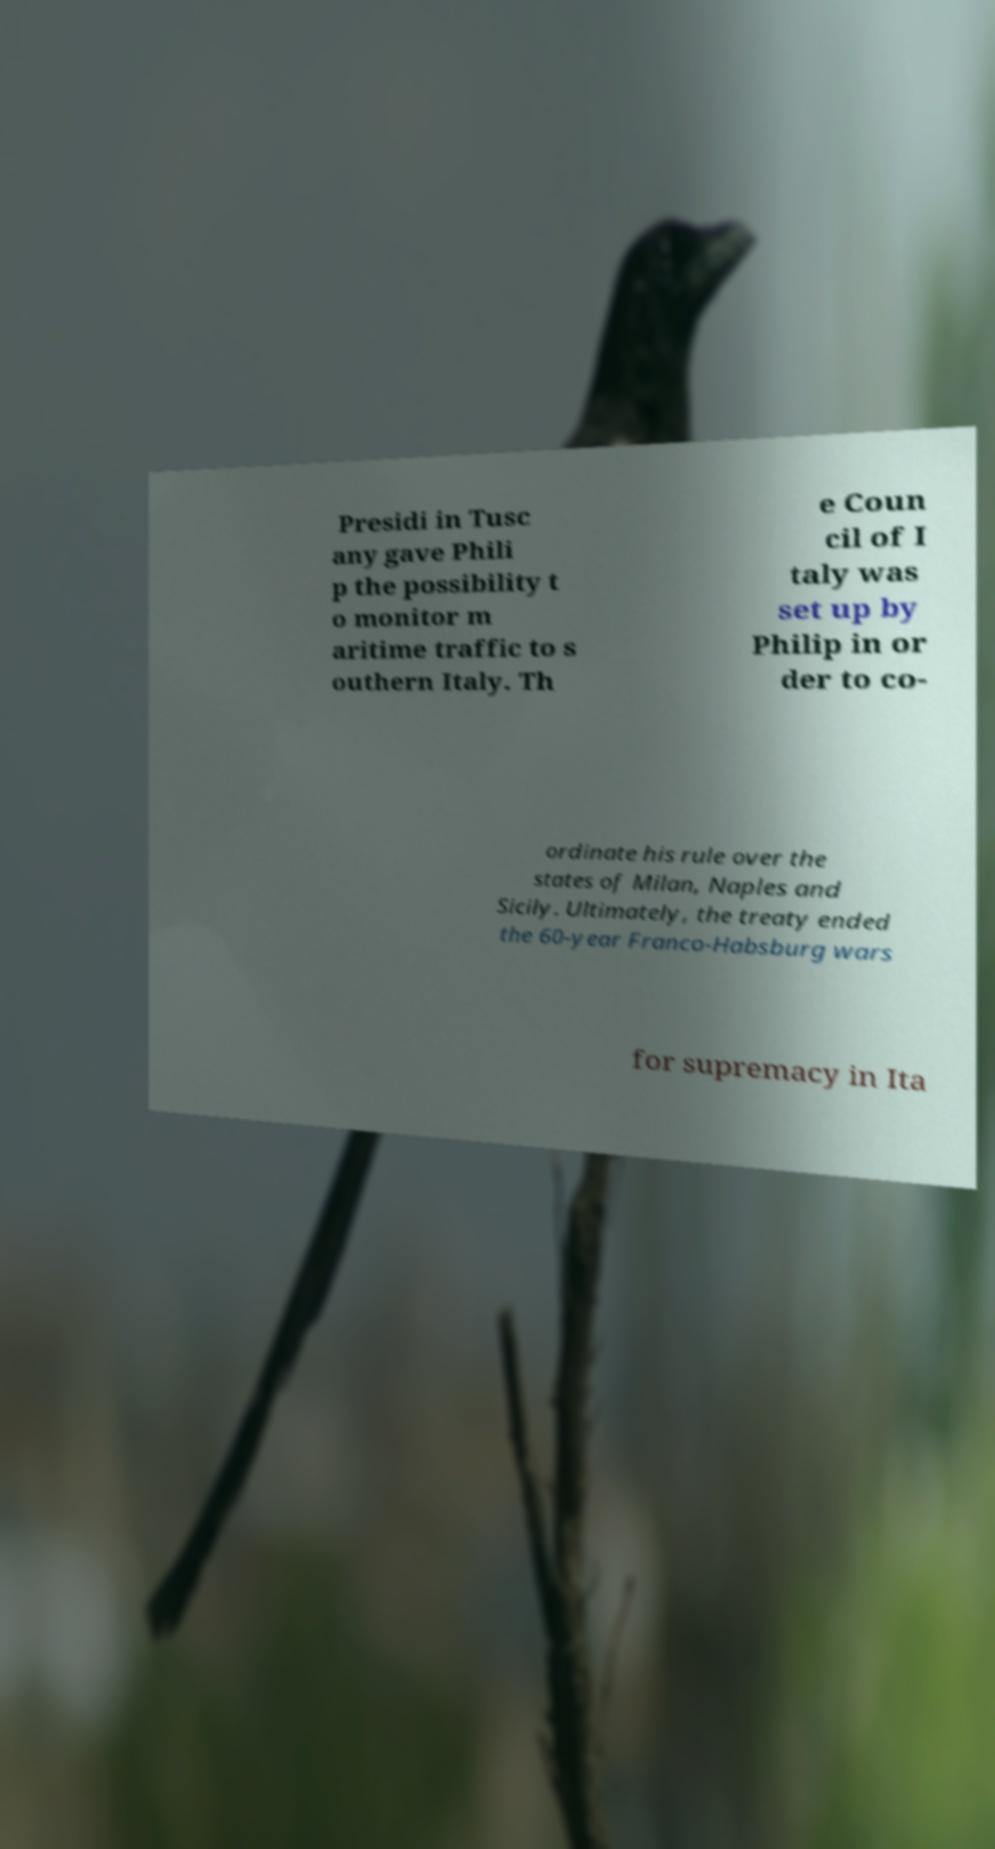Please read and relay the text visible in this image. What does it say? Presidi in Tusc any gave Phili p the possibility t o monitor m aritime traffic to s outhern Italy. Th e Coun cil of I taly was set up by Philip in or der to co- ordinate his rule over the states of Milan, Naples and Sicily. Ultimately, the treaty ended the 60-year Franco-Habsburg wars for supremacy in Ita 